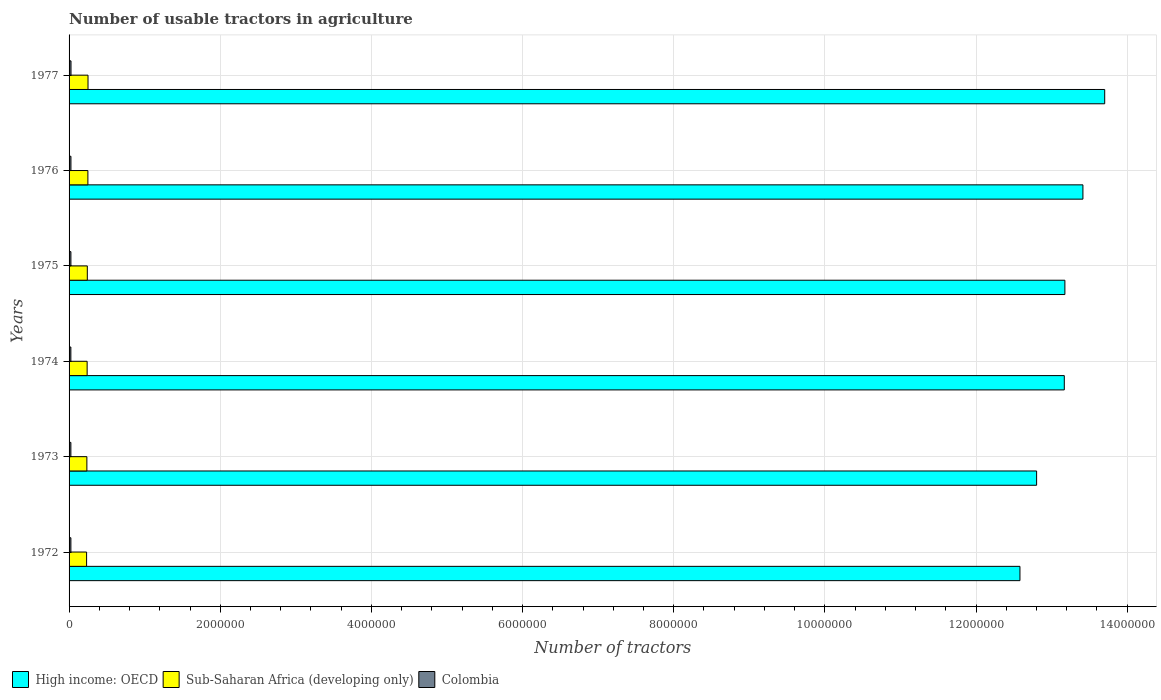Are the number of bars on each tick of the Y-axis equal?
Your answer should be compact. Yes. How many bars are there on the 1st tick from the top?
Provide a succinct answer. 3. What is the label of the 3rd group of bars from the top?
Provide a succinct answer. 1975. In how many cases, is the number of bars for a given year not equal to the number of legend labels?
Your response must be concise. 0. What is the number of usable tractors in agriculture in Colombia in 1977?
Provide a succinct answer. 2.56e+04. Across all years, what is the maximum number of usable tractors in agriculture in Sub-Saharan Africa (developing only)?
Make the answer very short. 2.51e+05. Across all years, what is the minimum number of usable tractors in agriculture in Sub-Saharan Africa (developing only)?
Your answer should be very brief. 2.32e+05. In which year was the number of usable tractors in agriculture in High income: OECD maximum?
Make the answer very short. 1977. What is the total number of usable tractors in agriculture in Colombia in the graph?
Ensure brevity in your answer.  1.46e+05. What is the difference between the number of usable tractors in agriculture in High income: OECD in 1973 and that in 1975?
Ensure brevity in your answer.  -3.74e+05. What is the difference between the number of usable tractors in agriculture in Colombia in 1977 and the number of usable tractors in agriculture in Sub-Saharan Africa (developing only) in 1975?
Offer a terse response. -2.16e+05. What is the average number of usable tractors in agriculture in Colombia per year?
Offer a terse response. 2.43e+04. In the year 1973, what is the difference between the number of usable tractors in agriculture in Sub-Saharan Africa (developing only) and number of usable tractors in agriculture in Colombia?
Give a very brief answer. 2.12e+05. What is the ratio of the number of usable tractors in agriculture in High income: OECD in 1972 to that in 1976?
Keep it short and to the point. 0.94. Is the number of usable tractors in agriculture in Colombia in 1973 less than that in 1976?
Provide a short and direct response. Yes. What is the difference between the highest and the second highest number of usable tractors in agriculture in Colombia?
Offer a very short reply. 973. What is the difference between the highest and the lowest number of usable tractors in agriculture in Sub-Saharan Africa (developing only)?
Give a very brief answer. 1.89e+04. What does the 2nd bar from the top in 1977 represents?
Give a very brief answer. Sub-Saharan Africa (developing only). What does the 2nd bar from the bottom in 1974 represents?
Give a very brief answer. Sub-Saharan Africa (developing only). Are the values on the major ticks of X-axis written in scientific E-notation?
Your answer should be compact. No. Does the graph contain any zero values?
Provide a short and direct response. No. Where does the legend appear in the graph?
Provide a succinct answer. Bottom left. How many legend labels are there?
Ensure brevity in your answer.  3. How are the legend labels stacked?
Your response must be concise. Horizontal. What is the title of the graph?
Provide a succinct answer. Number of usable tractors in agriculture. Does "United Kingdom" appear as one of the legend labels in the graph?
Provide a short and direct response. No. What is the label or title of the X-axis?
Keep it short and to the point. Number of tractors. What is the Number of tractors in High income: OECD in 1972?
Offer a very short reply. 1.26e+07. What is the Number of tractors of Sub-Saharan Africa (developing only) in 1972?
Provide a short and direct response. 2.32e+05. What is the Number of tractors in Colombia in 1972?
Give a very brief answer. 2.41e+04. What is the Number of tractors in High income: OECD in 1973?
Your response must be concise. 1.28e+07. What is the Number of tractors of Sub-Saharan Africa (developing only) in 1973?
Provide a succinct answer. 2.36e+05. What is the Number of tractors in Colombia in 1973?
Offer a terse response. 2.38e+04. What is the Number of tractors in High income: OECD in 1974?
Ensure brevity in your answer.  1.32e+07. What is the Number of tractors in Sub-Saharan Africa (developing only) in 1974?
Offer a very short reply. 2.39e+05. What is the Number of tractors of Colombia in 1974?
Your answer should be compact. 2.38e+04. What is the Number of tractors of High income: OECD in 1975?
Offer a terse response. 1.32e+07. What is the Number of tractors of Sub-Saharan Africa (developing only) in 1975?
Your answer should be very brief. 2.41e+05. What is the Number of tractors of Colombia in 1975?
Your answer should be very brief. 2.42e+04. What is the Number of tractors in High income: OECD in 1976?
Provide a short and direct response. 1.34e+07. What is the Number of tractors of Sub-Saharan Africa (developing only) in 1976?
Your answer should be very brief. 2.49e+05. What is the Number of tractors of Colombia in 1976?
Provide a short and direct response. 2.46e+04. What is the Number of tractors in High income: OECD in 1977?
Give a very brief answer. 1.37e+07. What is the Number of tractors in Sub-Saharan Africa (developing only) in 1977?
Give a very brief answer. 2.51e+05. What is the Number of tractors of Colombia in 1977?
Your response must be concise. 2.56e+04. Across all years, what is the maximum Number of tractors of High income: OECD?
Provide a short and direct response. 1.37e+07. Across all years, what is the maximum Number of tractors in Sub-Saharan Africa (developing only)?
Your response must be concise. 2.51e+05. Across all years, what is the maximum Number of tractors of Colombia?
Offer a very short reply. 2.56e+04. Across all years, what is the minimum Number of tractors in High income: OECD?
Offer a very short reply. 1.26e+07. Across all years, what is the minimum Number of tractors of Sub-Saharan Africa (developing only)?
Offer a terse response. 2.32e+05. Across all years, what is the minimum Number of tractors of Colombia?
Ensure brevity in your answer.  2.38e+04. What is the total Number of tractors of High income: OECD in the graph?
Your answer should be compact. 7.88e+07. What is the total Number of tractors in Sub-Saharan Africa (developing only) in the graph?
Ensure brevity in your answer.  1.45e+06. What is the total Number of tractors in Colombia in the graph?
Your response must be concise. 1.46e+05. What is the difference between the Number of tractors in High income: OECD in 1972 and that in 1973?
Your answer should be very brief. -2.21e+05. What is the difference between the Number of tractors in Sub-Saharan Africa (developing only) in 1972 and that in 1973?
Your answer should be compact. -3768. What is the difference between the Number of tractors of Colombia in 1972 and that in 1973?
Your response must be concise. 251. What is the difference between the Number of tractors of High income: OECD in 1972 and that in 1974?
Ensure brevity in your answer.  -5.87e+05. What is the difference between the Number of tractors in Sub-Saharan Africa (developing only) in 1972 and that in 1974?
Provide a succinct answer. -7165. What is the difference between the Number of tractors of Colombia in 1972 and that in 1974?
Make the answer very short. 298. What is the difference between the Number of tractors in High income: OECD in 1972 and that in 1975?
Offer a terse response. -5.95e+05. What is the difference between the Number of tractors of Sub-Saharan Africa (developing only) in 1972 and that in 1975?
Ensure brevity in your answer.  -9473. What is the difference between the Number of tractors of Colombia in 1972 and that in 1975?
Ensure brevity in your answer.  -136. What is the difference between the Number of tractors of High income: OECD in 1972 and that in 1976?
Offer a very short reply. -8.33e+05. What is the difference between the Number of tractors in Sub-Saharan Africa (developing only) in 1972 and that in 1976?
Give a very brief answer. -1.71e+04. What is the difference between the Number of tractors in Colombia in 1972 and that in 1976?
Your answer should be very brief. -570. What is the difference between the Number of tractors of High income: OECD in 1972 and that in 1977?
Keep it short and to the point. -1.12e+06. What is the difference between the Number of tractors of Sub-Saharan Africa (developing only) in 1972 and that in 1977?
Your answer should be compact. -1.89e+04. What is the difference between the Number of tractors of Colombia in 1972 and that in 1977?
Make the answer very short. -1543. What is the difference between the Number of tractors of High income: OECD in 1973 and that in 1974?
Your answer should be very brief. -3.66e+05. What is the difference between the Number of tractors of Sub-Saharan Africa (developing only) in 1973 and that in 1974?
Your answer should be very brief. -3397. What is the difference between the Number of tractors in High income: OECD in 1973 and that in 1975?
Keep it short and to the point. -3.74e+05. What is the difference between the Number of tractors in Sub-Saharan Africa (developing only) in 1973 and that in 1975?
Make the answer very short. -5705. What is the difference between the Number of tractors of Colombia in 1973 and that in 1975?
Keep it short and to the point. -387. What is the difference between the Number of tractors in High income: OECD in 1973 and that in 1976?
Provide a succinct answer. -6.13e+05. What is the difference between the Number of tractors of Sub-Saharan Africa (developing only) in 1973 and that in 1976?
Keep it short and to the point. -1.33e+04. What is the difference between the Number of tractors in Colombia in 1973 and that in 1976?
Offer a very short reply. -821. What is the difference between the Number of tractors in High income: OECD in 1973 and that in 1977?
Your response must be concise. -9.01e+05. What is the difference between the Number of tractors in Sub-Saharan Africa (developing only) in 1973 and that in 1977?
Offer a very short reply. -1.52e+04. What is the difference between the Number of tractors of Colombia in 1973 and that in 1977?
Ensure brevity in your answer.  -1794. What is the difference between the Number of tractors of High income: OECD in 1974 and that in 1975?
Offer a terse response. -7931. What is the difference between the Number of tractors in Sub-Saharan Africa (developing only) in 1974 and that in 1975?
Your response must be concise. -2308. What is the difference between the Number of tractors in Colombia in 1974 and that in 1975?
Your response must be concise. -434. What is the difference between the Number of tractors in High income: OECD in 1974 and that in 1976?
Your answer should be compact. -2.46e+05. What is the difference between the Number of tractors of Sub-Saharan Africa (developing only) in 1974 and that in 1976?
Make the answer very short. -9945. What is the difference between the Number of tractors of Colombia in 1974 and that in 1976?
Keep it short and to the point. -868. What is the difference between the Number of tractors in High income: OECD in 1974 and that in 1977?
Offer a terse response. -5.35e+05. What is the difference between the Number of tractors of Sub-Saharan Africa (developing only) in 1974 and that in 1977?
Keep it short and to the point. -1.18e+04. What is the difference between the Number of tractors in Colombia in 1974 and that in 1977?
Provide a short and direct response. -1841. What is the difference between the Number of tractors of High income: OECD in 1975 and that in 1976?
Keep it short and to the point. -2.39e+05. What is the difference between the Number of tractors of Sub-Saharan Africa (developing only) in 1975 and that in 1976?
Your answer should be very brief. -7637. What is the difference between the Number of tractors of Colombia in 1975 and that in 1976?
Keep it short and to the point. -434. What is the difference between the Number of tractors in High income: OECD in 1975 and that in 1977?
Your answer should be compact. -5.27e+05. What is the difference between the Number of tractors of Sub-Saharan Africa (developing only) in 1975 and that in 1977?
Keep it short and to the point. -9449. What is the difference between the Number of tractors in Colombia in 1975 and that in 1977?
Provide a succinct answer. -1407. What is the difference between the Number of tractors in High income: OECD in 1976 and that in 1977?
Offer a terse response. -2.88e+05. What is the difference between the Number of tractors of Sub-Saharan Africa (developing only) in 1976 and that in 1977?
Keep it short and to the point. -1812. What is the difference between the Number of tractors in Colombia in 1976 and that in 1977?
Ensure brevity in your answer.  -973. What is the difference between the Number of tractors of High income: OECD in 1972 and the Number of tractors of Sub-Saharan Africa (developing only) in 1973?
Your answer should be very brief. 1.23e+07. What is the difference between the Number of tractors of High income: OECD in 1972 and the Number of tractors of Colombia in 1973?
Your answer should be very brief. 1.26e+07. What is the difference between the Number of tractors in Sub-Saharan Africa (developing only) in 1972 and the Number of tractors in Colombia in 1973?
Provide a succinct answer. 2.08e+05. What is the difference between the Number of tractors of High income: OECD in 1972 and the Number of tractors of Sub-Saharan Africa (developing only) in 1974?
Ensure brevity in your answer.  1.23e+07. What is the difference between the Number of tractors in High income: OECD in 1972 and the Number of tractors in Colombia in 1974?
Offer a very short reply. 1.26e+07. What is the difference between the Number of tractors in Sub-Saharan Africa (developing only) in 1972 and the Number of tractors in Colombia in 1974?
Offer a very short reply. 2.08e+05. What is the difference between the Number of tractors of High income: OECD in 1972 and the Number of tractors of Sub-Saharan Africa (developing only) in 1975?
Keep it short and to the point. 1.23e+07. What is the difference between the Number of tractors of High income: OECD in 1972 and the Number of tractors of Colombia in 1975?
Keep it short and to the point. 1.26e+07. What is the difference between the Number of tractors of Sub-Saharan Africa (developing only) in 1972 and the Number of tractors of Colombia in 1975?
Your response must be concise. 2.08e+05. What is the difference between the Number of tractors of High income: OECD in 1972 and the Number of tractors of Sub-Saharan Africa (developing only) in 1976?
Offer a terse response. 1.23e+07. What is the difference between the Number of tractors of High income: OECD in 1972 and the Number of tractors of Colombia in 1976?
Make the answer very short. 1.26e+07. What is the difference between the Number of tractors in Sub-Saharan Africa (developing only) in 1972 and the Number of tractors in Colombia in 1976?
Offer a very short reply. 2.07e+05. What is the difference between the Number of tractors in High income: OECD in 1972 and the Number of tractors in Sub-Saharan Africa (developing only) in 1977?
Ensure brevity in your answer.  1.23e+07. What is the difference between the Number of tractors of High income: OECD in 1972 and the Number of tractors of Colombia in 1977?
Give a very brief answer. 1.26e+07. What is the difference between the Number of tractors of Sub-Saharan Africa (developing only) in 1972 and the Number of tractors of Colombia in 1977?
Your answer should be very brief. 2.06e+05. What is the difference between the Number of tractors in High income: OECD in 1973 and the Number of tractors in Sub-Saharan Africa (developing only) in 1974?
Your answer should be compact. 1.26e+07. What is the difference between the Number of tractors in High income: OECD in 1973 and the Number of tractors in Colombia in 1974?
Offer a very short reply. 1.28e+07. What is the difference between the Number of tractors in Sub-Saharan Africa (developing only) in 1973 and the Number of tractors in Colombia in 1974?
Make the answer very short. 2.12e+05. What is the difference between the Number of tractors of High income: OECD in 1973 and the Number of tractors of Sub-Saharan Africa (developing only) in 1975?
Keep it short and to the point. 1.26e+07. What is the difference between the Number of tractors in High income: OECD in 1973 and the Number of tractors in Colombia in 1975?
Your response must be concise. 1.28e+07. What is the difference between the Number of tractors in Sub-Saharan Africa (developing only) in 1973 and the Number of tractors in Colombia in 1975?
Your answer should be very brief. 2.11e+05. What is the difference between the Number of tractors of High income: OECD in 1973 and the Number of tractors of Sub-Saharan Africa (developing only) in 1976?
Your answer should be very brief. 1.26e+07. What is the difference between the Number of tractors in High income: OECD in 1973 and the Number of tractors in Colombia in 1976?
Your answer should be very brief. 1.28e+07. What is the difference between the Number of tractors in Sub-Saharan Africa (developing only) in 1973 and the Number of tractors in Colombia in 1976?
Keep it short and to the point. 2.11e+05. What is the difference between the Number of tractors in High income: OECD in 1973 and the Number of tractors in Sub-Saharan Africa (developing only) in 1977?
Give a very brief answer. 1.26e+07. What is the difference between the Number of tractors of High income: OECD in 1973 and the Number of tractors of Colombia in 1977?
Give a very brief answer. 1.28e+07. What is the difference between the Number of tractors in Sub-Saharan Africa (developing only) in 1973 and the Number of tractors in Colombia in 1977?
Your response must be concise. 2.10e+05. What is the difference between the Number of tractors of High income: OECD in 1974 and the Number of tractors of Sub-Saharan Africa (developing only) in 1975?
Ensure brevity in your answer.  1.29e+07. What is the difference between the Number of tractors in High income: OECD in 1974 and the Number of tractors in Colombia in 1975?
Provide a succinct answer. 1.31e+07. What is the difference between the Number of tractors in Sub-Saharan Africa (developing only) in 1974 and the Number of tractors in Colombia in 1975?
Offer a very short reply. 2.15e+05. What is the difference between the Number of tractors in High income: OECD in 1974 and the Number of tractors in Sub-Saharan Africa (developing only) in 1976?
Your answer should be compact. 1.29e+07. What is the difference between the Number of tractors of High income: OECD in 1974 and the Number of tractors of Colombia in 1976?
Your response must be concise. 1.31e+07. What is the difference between the Number of tractors in Sub-Saharan Africa (developing only) in 1974 and the Number of tractors in Colombia in 1976?
Your response must be concise. 2.14e+05. What is the difference between the Number of tractors in High income: OECD in 1974 and the Number of tractors in Sub-Saharan Africa (developing only) in 1977?
Your answer should be very brief. 1.29e+07. What is the difference between the Number of tractors in High income: OECD in 1974 and the Number of tractors in Colombia in 1977?
Offer a very short reply. 1.31e+07. What is the difference between the Number of tractors of Sub-Saharan Africa (developing only) in 1974 and the Number of tractors of Colombia in 1977?
Provide a short and direct response. 2.13e+05. What is the difference between the Number of tractors in High income: OECD in 1975 and the Number of tractors in Sub-Saharan Africa (developing only) in 1976?
Your answer should be very brief. 1.29e+07. What is the difference between the Number of tractors of High income: OECD in 1975 and the Number of tractors of Colombia in 1976?
Your answer should be compact. 1.32e+07. What is the difference between the Number of tractors of Sub-Saharan Africa (developing only) in 1975 and the Number of tractors of Colombia in 1976?
Your response must be concise. 2.17e+05. What is the difference between the Number of tractors in High income: OECD in 1975 and the Number of tractors in Sub-Saharan Africa (developing only) in 1977?
Ensure brevity in your answer.  1.29e+07. What is the difference between the Number of tractors in High income: OECD in 1975 and the Number of tractors in Colombia in 1977?
Offer a very short reply. 1.32e+07. What is the difference between the Number of tractors of Sub-Saharan Africa (developing only) in 1975 and the Number of tractors of Colombia in 1977?
Your answer should be very brief. 2.16e+05. What is the difference between the Number of tractors in High income: OECD in 1976 and the Number of tractors in Sub-Saharan Africa (developing only) in 1977?
Give a very brief answer. 1.32e+07. What is the difference between the Number of tractors in High income: OECD in 1976 and the Number of tractors in Colombia in 1977?
Offer a very short reply. 1.34e+07. What is the difference between the Number of tractors of Sub-Saharan Africa (developing only) in 1976 and the Number of tractors of Colombia in 1977?
Your response must be concise. 2.23e+05. What is the average Number of tractors of High income: OECD per year?
Keep it short and to the point. 1.31e+07. What is the average Number of tractors of Sub-Saharan Africa (developing only) per year?
Your response must be concise. 2.41e+05. What is the average Number of tractors of Colombia per year?
Ensure brevity in your answer.  2.43e+04. In the year 1972, what is the difference between the Number of tractors in High income: OECD and Number of tractors in Sub-Saharan Africa (developing only)?
Give a very brief answer. 1.23e+07. In the year 1972, what is the difference between the Number of tractors in High income: OECD and Number of tractors in Colombia?
Offer a terse response. 1.26e+07. In the year 1972, what is the difference between the Number of tractors in Sub-Saharan Africa (developing only) and Number of tractors in Colombia?
Provide a succinct answer. 2.08e+05. In the year 1973, what is the difference between the Number of tractors of High income: OECD and Number of tractors of Sub-Saharan Africa (developing only)?
Make the answer very short. 1.26e+07. In the year 1973, what is the difference between the Number of tractors in High income: OECD and Number of tractors in Colombia?
Provide a succinct answer. 1.28e+07. In the year 1973, what is the difference between the Number of tractors in Sub-Saharan Africa (developing only) and Number of tractors in Colombia?
Make the answer very short. 2.12e+05. In the year 1974, what is the difference between the Number of tractors in High income: OECD and Number of tractors in Sub-Saharan Africa (developing only)?
Provide a short and direct response. 1.29e+07. In the year 1974, what is the difference between the Number of tractors in High income: OECD and Number of tractors in Colombia?
Offer a very short reply. 1.31e+07. In the year 1974, what is the difference between the Number of tractors in Sub-Saharan Africa (developing only) and Number of tractors in Colombia?
Your response must be concise. 2.15e+05. In the year 1975, what is the difference between the Number of tractors in High income: OECD and Number of tractors in Sub-Saharan Africa (developing only)?
Your answer should be very brief. 1.29e+07. In the year 1975, what is the difference between the Number of tractors of High income: OECD and Number of tractors of Colombia?
Give a very brief answer. 1.32e+07. In the year 1975, what is the difference between the Number of tractors of Sub-Saharan Africa (developing only) and Number of tractors of Colombia?
Keep it short and to the point. 2.17e+05. In the year 1976, what is the difference between the Number of tractors of High income: OECD and Number of tractors of Sub-Saharan Africa (developing only)?
Offer a terse response. 1.32e+07. In the year 1976, what is the difference between the Number of tractors of High income: OECD and Number of tractors of Colombia?
Provide a succinct answer. 1.34e+07. In the year 1976, what is the difference between the Number of tractors in Sub-Saharan Africa (developing only) and Number of tractors in Colombia?
Keep it short and to the point. 2.24e+05. In the year 1977, what is the difference between the Number of tractors of High income: OECD and Number of tractors of Sub-Saharan Africa (developing only)?
Ensure brevity in your answer.  1.35e+07. In the year 1977, what is the difference between the Number of tractors of High income: OECD and Number of tractors of Colombia?
Provide a short and direct response. 1.37e+07. In the year 1977, what is the difference between the Number of tractors of Sub-Saharan Africa (developing only) and Number of tractors of Colombia?
Make the answer very short. 2.25e+05. What is the ratio of the Number of tractors of High income: OECD in 1972 to that in 1973?
Give a very brief answer. 0.98. What is the ratio of the Number of tractors in Sub-Saharan Africa (developing only) in 1972 to that in 1973?
Offer a terse response. 0.98. What is the ratio of the Number of tractors in Colombia in 1972 to that in 1973?
Ensure brevity in your answer.  1.01. What is the ratio of the Number of tractors of High income: OECD in 1972 to that in 1974?
Your answer should be very brief. 0.96. What is the ratio of the Number of tractors in Sub-Saharan Africa (developing only) in 1972 to that in 1974?
Make the answer very short. 0.97. What is the ratio of the Number of tractors of Colombia in 1972 to that in 1974?
Make the answer very short. 1.01. What is the ratio of the Number of tractors in High income: OECD in 1972 to that in 1975?
Provide a short and direct response. 0.95. What is the ratio of the Number of tractors in Sub-Saharan Africa (developing only) in 1972 to that in 1975?
Your answer should be very brief. 0.96. What is the ratio of the Number of tractors in High income: OECD in 1972 to that in 1976?
Ensure brevity in your answer.  0.94. What is the ratio of the Number of tractors in Sub-Saharan Africa (developing only) in 1972 to that in 1976?
Provide a short and direct response. 0.93. What is the ratio of the Number of tractors of Colombia in 1972 to that in 1976?
Your response must be concise. 0.98. What is the ratio of the Number of tractors of High income: OECD in 1972 to that in 1977?
Give a very brief answer. 0.92. What is the ratio of the Number of tractors in Sub-Saharan Africa (developing only) in 1972 to that in 1977?
Offer a very short reply. 0.92. What is the ratio of the Number of tractors in Colombia in 1972 to that in 1977?
Provide a succinct answer. 0.94. What is the ratio of the Number of tractors in High income: OECD in 1973 to that in 1974?
Offer a very short reply. 0.97. What is the ratio of the Number of tractors in Sub-Saharan Africa (developing only) in 1973 to that in 1974?
Your answer should be compact. 0.99. What is the ratio of the Number of tractors in Colombia in 1973 to that in 1974?
Offer a terse response. 1. What is the ratio of the Number of tractors in High income: OECD in 1973 to that in 1975?
Ensure brevity in your answer.  0.97. What is the ratio of the Number of tractors in Sub-Saharan Africa (developing only) in 1973 to that in 1975?
Your answer should be very brief. 0.98. What is the ratio of the Number of tractors of High income: OECD in 1973 to that in 1976?
Your answer should be very brief. 0.95. What is the ratio of the Number of tractors in Sub-Saharan Africa (developing only) in 1973 to that in 1976?
Provide a short and direct response. 0.95. What is the ratio of the Number of tractors of Colombia in 1973 to that in 1976?
Your response must be concise. 0.97. What is the ratio of the Number of tractors of High income: OECD in 1973 to that in 1977?
Offer a terse response. 0.93. What is the ratio of the Number of tractors in Sub-Saharan Africa (developing only) in 1973 to that in 1977?
Provide a succinct answer. 0.94. What is the ratio of the Number of tractors of Colombia in 1973 to that in 1977?
Offer a terse response. 0.93. What is the ratio of the Number of tractors of High income: OECD in 1974 to that in 1975?
Provide a short and direct response. 1. What is the ratio of the Number of tractors in Sub-Saharan Africa (developing only) in 1974 to that in 1975?
Make the answer very short. 0.99. What is the ratio of the Number of tractors in Colombia in 1974 to that in 1975?
Ensure brevity in your answer.  0.98. What is the ratio of the Number of tractors in High income: OECD in 1974 to that in 1976?
Give a very brief answer. 0.98. What is the ratio of the Number of tractors of Sub-Saharan Africa (developing only) in 1974 to that in 1976?
Provide a short and direct response. 0.96. What is the ratio of the Number of tractors of Colombia in 1974 to that in 1976?
Offer a very short reply. 0.96. What is the ratio of the Number of tractors in High income: OECD in 1974 to that in 1977?
Provide a short and direct response. 0.96. What is the ratio of the Number of tractors of Sub-Saharan Africa (developing only) in 1974 to that in 1977?
Ensure brevity in your answer.  0.95. What is the ratio of the Number of tractors of Colombia in 1974 to that in 1977?
Provide a succinct answer. 0.93. What is the ratio of the Number of tractors in High income: OECD in 1975 to that in 1976?
Provide a short and direct response. 0.98. What is the ratio of the Number of tractors of Sub-Saharan Africa (developing only) in 1975 to that in 1976?
Provide a succinct answer. 0.97. What is the ratio of the Number of tractors in Colombia in 1975 to that in 1976?
Keep it short and to the point. 0.98. What is the ratio of the Number of tractors in High income: OECD in 1975 to that in 1977?
Give a very brief answer. 0.96. What is the ratio of the Number of tractors in Sub-Saharan Africa (developing only) in 1975 to that in 1977?
Provide a succinct answer. 0.96. What is the ratio of the Number of tractors in Colombia in 1975 to that in 1977?
Provide a short and direct response. 0.94. What is the ratio of the Number of tractors in High income: OECD in 1976 to that in 1977?
Your response must be concise. 0.98. What is the ratio of the Number of tractors of Sub-Saharan Africa (developing only) in 1976 to that in 1977?
Provide a succinct answer. 0.99. What is the ratio of the Number of tractors in Colombia in 1976 to that in 1977?
Your answer should be compact. 0.96. What is the difference between the highest and the second highest Number of tractors of High income: OECD?
Provide a short and direct response. 2.88e+05. What is the difference between the highest and the second highest Number of tractors of Sub-Saharan Africa (developing only)?
Provide a succinct answer. 1812. What is the difference between the highest and the second highest Number of tractors of Colombia?
Your answer should be compact. 973. What is the difference between the highest and the lowest Number of tractors in High income: OECD?
Offer a terse response. 1.12e+06. What is the difference between the highest and the lowest Number of tractors in Sub-Saharan Africa (developing only)?
Offer a terse response. 1.89e+04. What is the difference between the highest and the lowest Number of tractors in Colombia?
Offer a very short reply. 1841. 